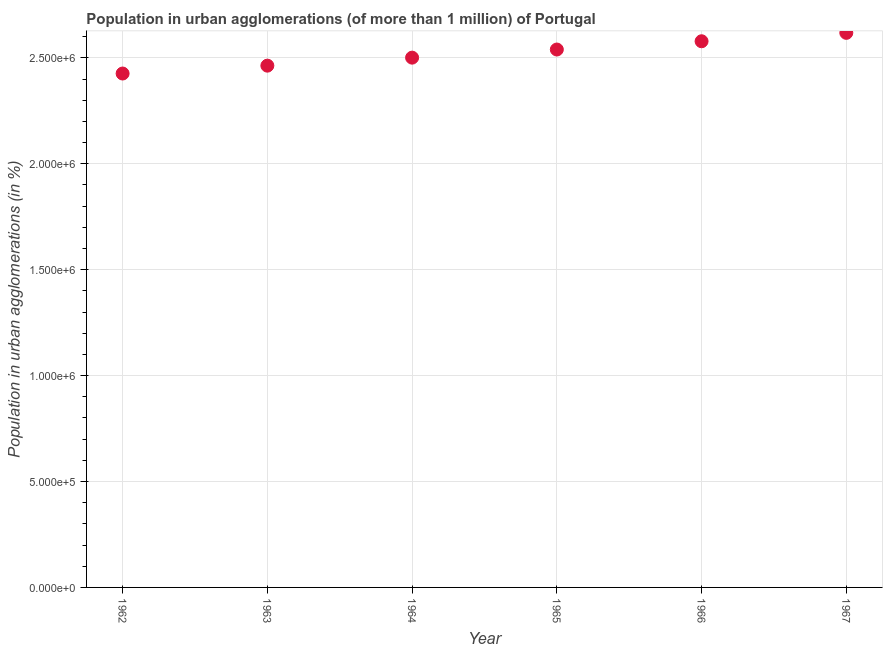What is the population in urban agglomerations in 1966?
Make the answer very short. 2.58e+06. Across all years, what is the maximum population in urban agglomerations?
Offer a terse response. 2.62e+06. Across all years, what is the minimum population in urban agglomerations?
Make the answer very short. 2.43e+06. In which year was the population in urban agglomerations maximum?
Provide a short and direct response. 1967. In which year was the population in urban agglomerations minimum?
Ensure brevity in your answer.  1962. What is the sum of the population in urban agglomerations?
Make the answer very short. 1.51e+07. What is the difference between the population in urban agglomerations in 1964 and 1967?
Offer a very short reply. -1.17e+05. What is the average population in urban agglomerations per year?
Give a very brief answer. 2.52e+06. What is the median population in urban agglomerations?
Your answer should be very brief. 2.52e+06. What is the ratio of the population in urban agglomerations in 1965 to that in 1967?
Give a very brief answer. 0.97. Is the population in urban agglomerations in 1964 less than that in 1967?
Ensure brevity in your answer.  Yes. What is the difference between the highest and the second highest population in urban agglomerations?
Your response must be concise. 3.97e+04. Is the sum of the population in urban agglomerations in 1964 and 1967 greater than the maximum population in urban agglomerations across all years?
Give a very brief answer. Yes. What is the difference between the highest and the lowest population in urban agglomerations?
Your answer should be compact. 1.92e+05. How many dotlines are there?
Ensure brevity in your answer.  1. Are the values on the major ticks of Y-axis written in scientific E-notation?
Offer a terse response. Yes. Does the graph contain grids?
Your response must be concise. Yes. What is the title of the graph?
Ensure brevity in your answer.  Population in urban agglomerations (of more than 1 million) of Portugal. What is the label or title of the X-axis?
Your response must be concise. Year. What is the label or title of the Y-axis?
Make the answer very short. Population in urban agglomerations (in %). What is the Population in urban agglomerations (in %) in 1962?
Make the answer very short. 2.43e+06. What is the Population in urban agglomerations (in %) in 1963?
Your answer should be compact. 2.46e+06. What is the Population in urban agglomerations (in %) in 1964?
Your answer should be compact. 2.50e+06. What is the Population in urban agglomerations (in %) in 1965?
Offer a terse response. 2.54e+06. What is the Population in urban agglomerations (in %) in 1966?
Your answer should be compact. 2.58e+06. What is the Population in urban agglomerations (in %) in 1967?
Provide a short and direct response. 2.62e+06. What is the difference between the Population in urban agglomerations (in %) in 1962 and 1963?
Give a very brief answer. -3.71e+04. What is the difference between the Population in urban agglomerations (in %) in 1962 and 1964?
Offer a terse response. -7.49e+04. What is the difference between the Population in urban agglomerations (in %) in 1962 and 1965?
Give a very brief answer. -1.13e+05. What is the difference between the Population in urban agglomerations (in %) in 1962 and 1966?
Keep it short and to the point. -1.52e+05. What is the difference between the Population in urban agglomerations (in %) in 1962 and 1967?
Give a very brief answer. -1.92e+05. What is the difference between the Population in urban agglomerations (in %) in 1963 and 1964?
Make the answer very short. -3.78e+04. What is the difference between the Population in urban agglomerations (in %) in 1963 and 1965?
Offer a terse response. -7.61e+04. What is the difference between the Population in urban agglomerations (in %) in 1963 and 1966?
Your answer should be compact. -1.15e+05. What is the difference between the Population in urban agglomerations (in %) in 1963 and 1967?
Your answer should be very brief. -1.55e+05. What is the difference between the Population in urban agglomerations (in %) in 1964 and 1965?
Ensure brevity in your answer.  -3.83e+04. What is the difference between the Population in urban agglomerations (in %) in 1964 and 1966?
Provide a succinct answer. -7.73e+04. What is the difference between the Population in urban agglomerations (in %) in 1964 and 1967?
Provide a short and direct response. -1.17e+05. What is the difference between the Population in urban agglomerations (in %) in 1965 and 1966?
Your response must be concise. -3.90e+04. What is the difference between the Population in urban agglomerations (in %) in 1965 and 1967?
Ensure brevity in your answer.  -7.87e+04. What is the difference between the Population in urban agglomerations (in %) in 1966 and 1967?
Keep it short and to the point. -3.97e+04. What is the ratio of the Population in urban agglomerations (in %) in 1962 to that in 1963?
Ensure brevity in your answer.  0.98. What is the ratio of the Population in urban agglomerations (in %) in 1962 to that in 1964?
Provide a short and direct response. 0.97. What is the ratio of the Population in urban agglomerations (in %) in 1962 to that in 1965?
Offer a very short reply. 0.95. What is the ratio of the Population in urban agglomerations (in %) in 1962 to that in 1966?
Make the answer very short. 0.94. What is the ratio of the Population in urban agglomerations (in %) in 1962 to that in 1967?
Your response must be concise. 0.93. What is the ratio of the Population in urban agglomerations (in %) in 1963 to that in 1964?
Ensure brevity in your answer.  0.98. What is the ratio of the Population in urban agglomerations (in %) in 1963 to that in 1965?
Offer a very short reply. 0.97. What is the ratio of the Population in urban agglomerations (in %) in 1963 to that in 1966?
Provide a succinct answer. 0.95. What is the ratio of the Population in urban agglomerations (in %) in 1963 to that in 1967?
Give a very brief answer. 0.94. What is the ratio of the Population in urban agglomerations (in %) in 1964 to that in 1965?
Keep it short and to the point. 0.98. What is the ratio of the Population in urban agglomerations (in %) in 1964 to that in 1966?
Keep it short and to the point. 0.97. What is the ratio of the Population in urban agglomerations (in %) in 1964 to that in 1967?
Ensure brevity in your answer.  0.95. 